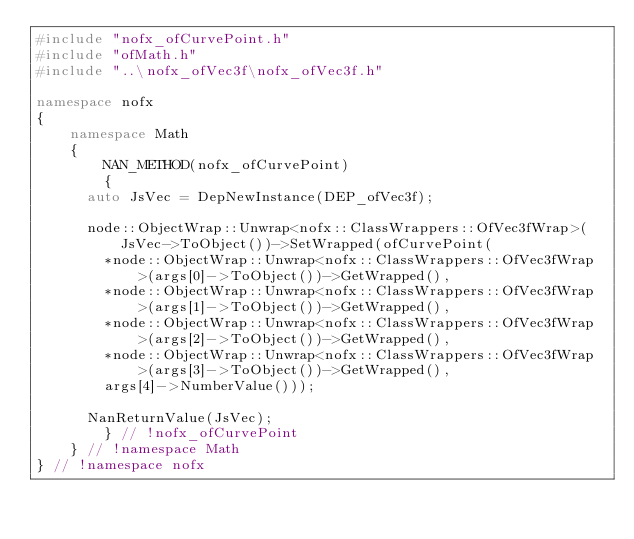<code> <loc_0><loc_0><loc_500><loc_500><_C++_>#include "nofx_ofCurvePoint.h"
#include "ofMath.h"
#include "..\nofx_ofVec3f\nofx_ofVec3f.h"

namespace nofx
{
    namespace Math
    {
        NAN_METHOD(nofx_ofCurvePoint)
        {
			auto JsVec = DepNewInstance(DEP_ofVec3f);

			node::ObjectWrap::Unwrap<nofx::ClassWrappers::OfVec3fWrap>(JsVec->ToObject())->SetWrapped(ofCurvePoint(
				*node::ObjectWrap::Unwrap<nofx::ClassWrappers::OfVec3fWrap>(args[0]->ToObject())->GetWrapped(),
				*node::ObjectWrap::Unwrap<nofx::ClassWrappers::OfVec3fWrap>(args[1]->ToObject())->GetWrapped(),
				*node::ObjectWrap::Unwrap<nofx::ClassWrappers::OfVec3fWrap>(args[2]->ToObject())->GetWrapped(),
				*node::ObjectWrap::Unwrap<nofx::ClassWrappers::OfVec3fWrap>(args[3]->ToObject())->GetWrapped(),
				args[4]->NumberValue()));

			NanReturnValue(JsVec);
        } // !nofx_ofCurvePoint
    } // !namespace Math
} // !namespace nofx</code> 